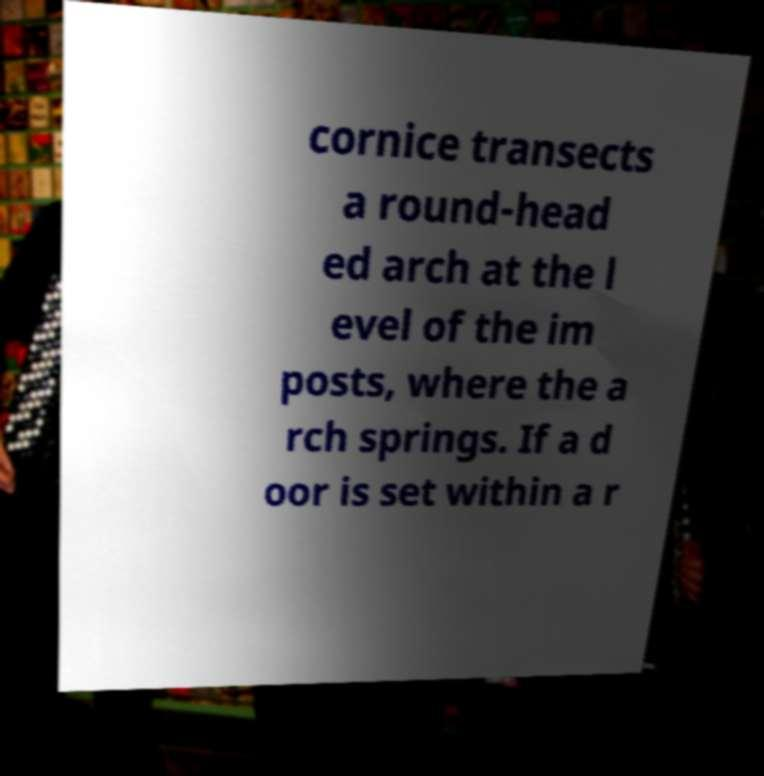What messages or text are displayed in this image? I need them in a readable, typed format. cornice transects a round-head ed arch at the l evel of the im posts, where the a rch springs. If a d oor is set within a r 